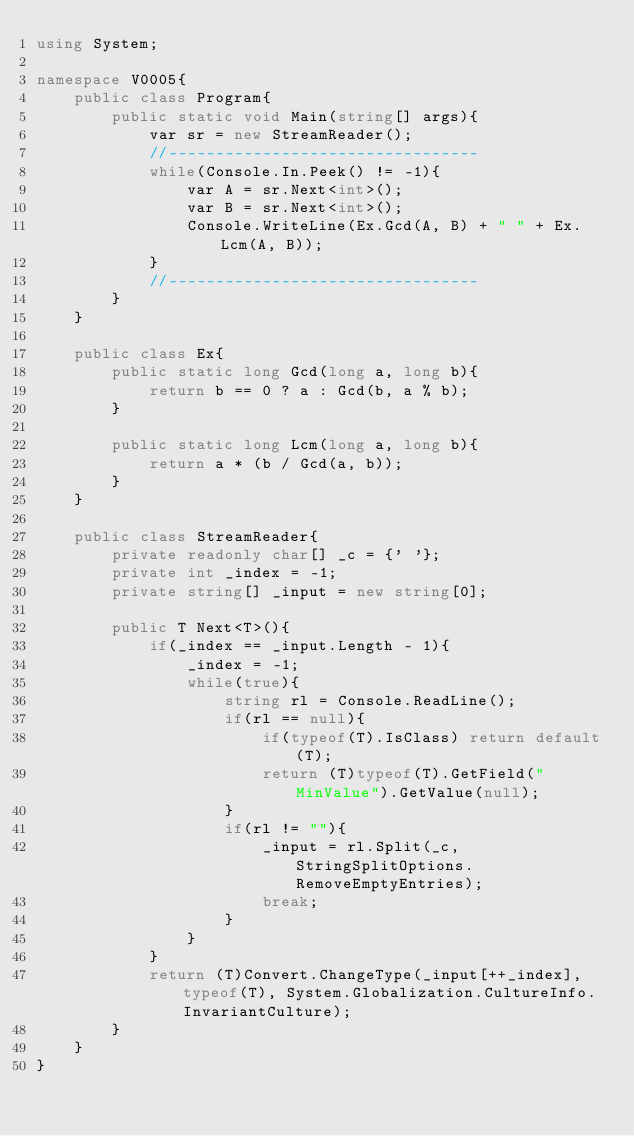Convert code to text. <code><loc_0><loc_0><loc_500><loc_500><_C#_>using System;

namespace V0005{
    public class Program{
        public static void Main(string[] args){
            var sr = new StreamReader();
            //---------------------------------
            while(Console.In.Peek() != -1){
                var A = sr.Next<int>();
                var B = sr.Next<int>();
                Console.WriteLine(Ex.Gcd(A, B) + " " + Ex.Lcm(A, B));
            }
            //---------------------------------
        }
    }

    public class Ex{
        public static long Gcd(long a, long b){
            return b == 0 ? a : Gcd(b, a % b);
        }

        public static long Lcm(long a, long b){
            return a * (b / Gcd(a, b));
        }
    }

    public class StreamReader{
        private readonly char[] _c = {' '};
        private int _index = -1;
        private string[] _input = new string[0];

        public T Next<T>(){
            if(_index == _input.Length - 1){
                _index = -1;
                while(true){
                    string rl = Console.ReadLine();
                    if(rl == null){
                        if(typeof(T).IsClass) return default(T);
                        return (T)typeof(T).GetField("MinValue").GetValue(null);
                    }
                    if(rl != ""){
                        _input = rl.Split(_c, StringSplitOptions.RemoveEmptyEntries);
                        break;
                    }
                }
            }
            return (T)Convert.ChangeType(_input[++_index], typeof(T), System.Globalization.CultureInfo.InvariantCulture);
        }
    }
}</code> 